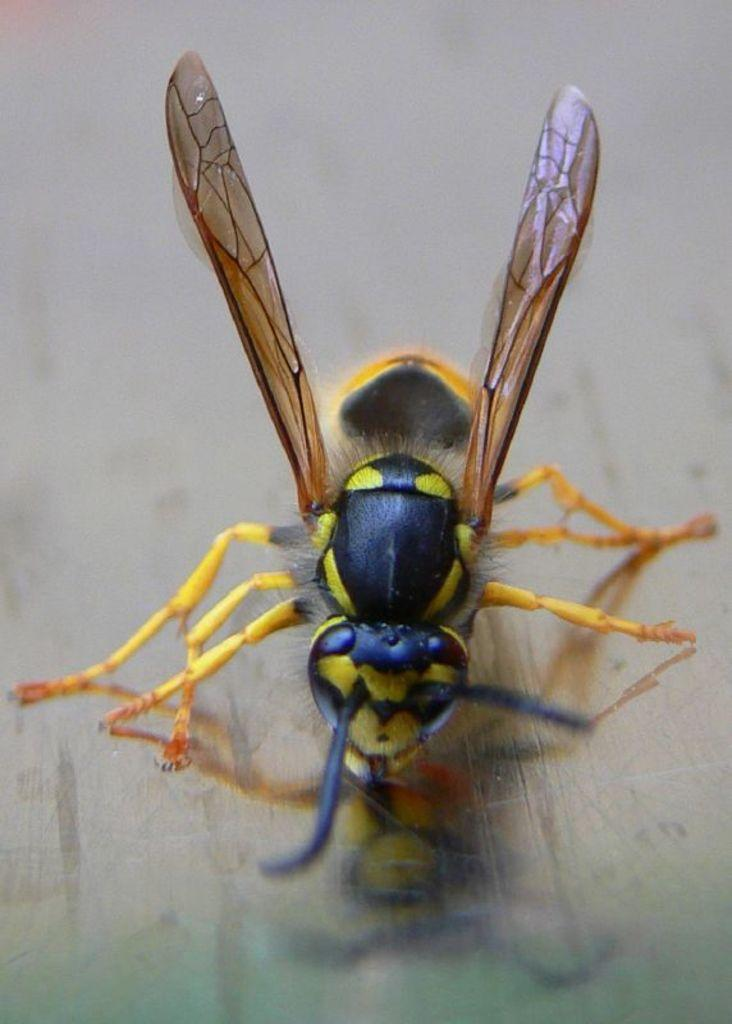What type of creature is present in the image? There is an insect in the image. What surface is the insect located on? The insect is on a wooden surface. What brand of toothpaste is the insect using in the image? There is no toothpaste present in the image, and insects do not use toothpaste. 